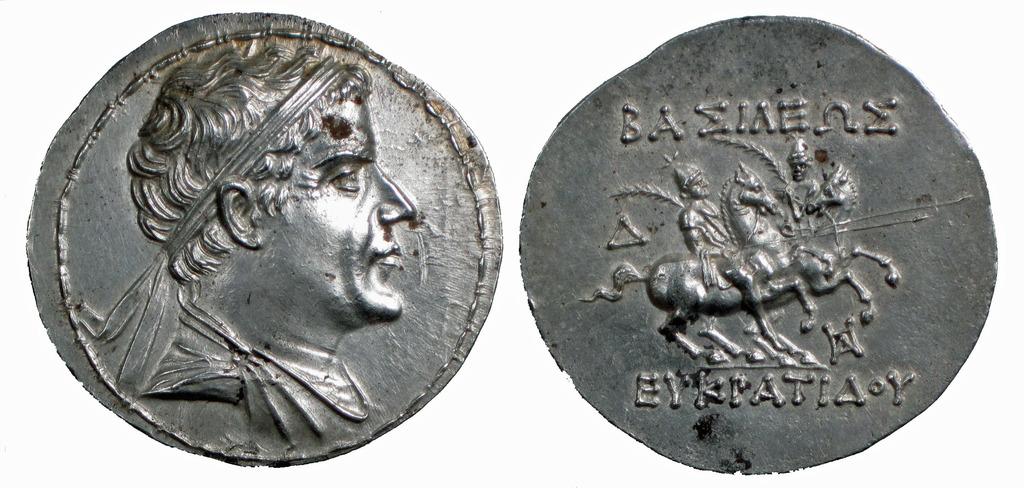What is the first letter seen on the right coin, at the top?
Give a very brief answer. B. What letter in on the bottom right?
Provide a succinct answer. Y. 